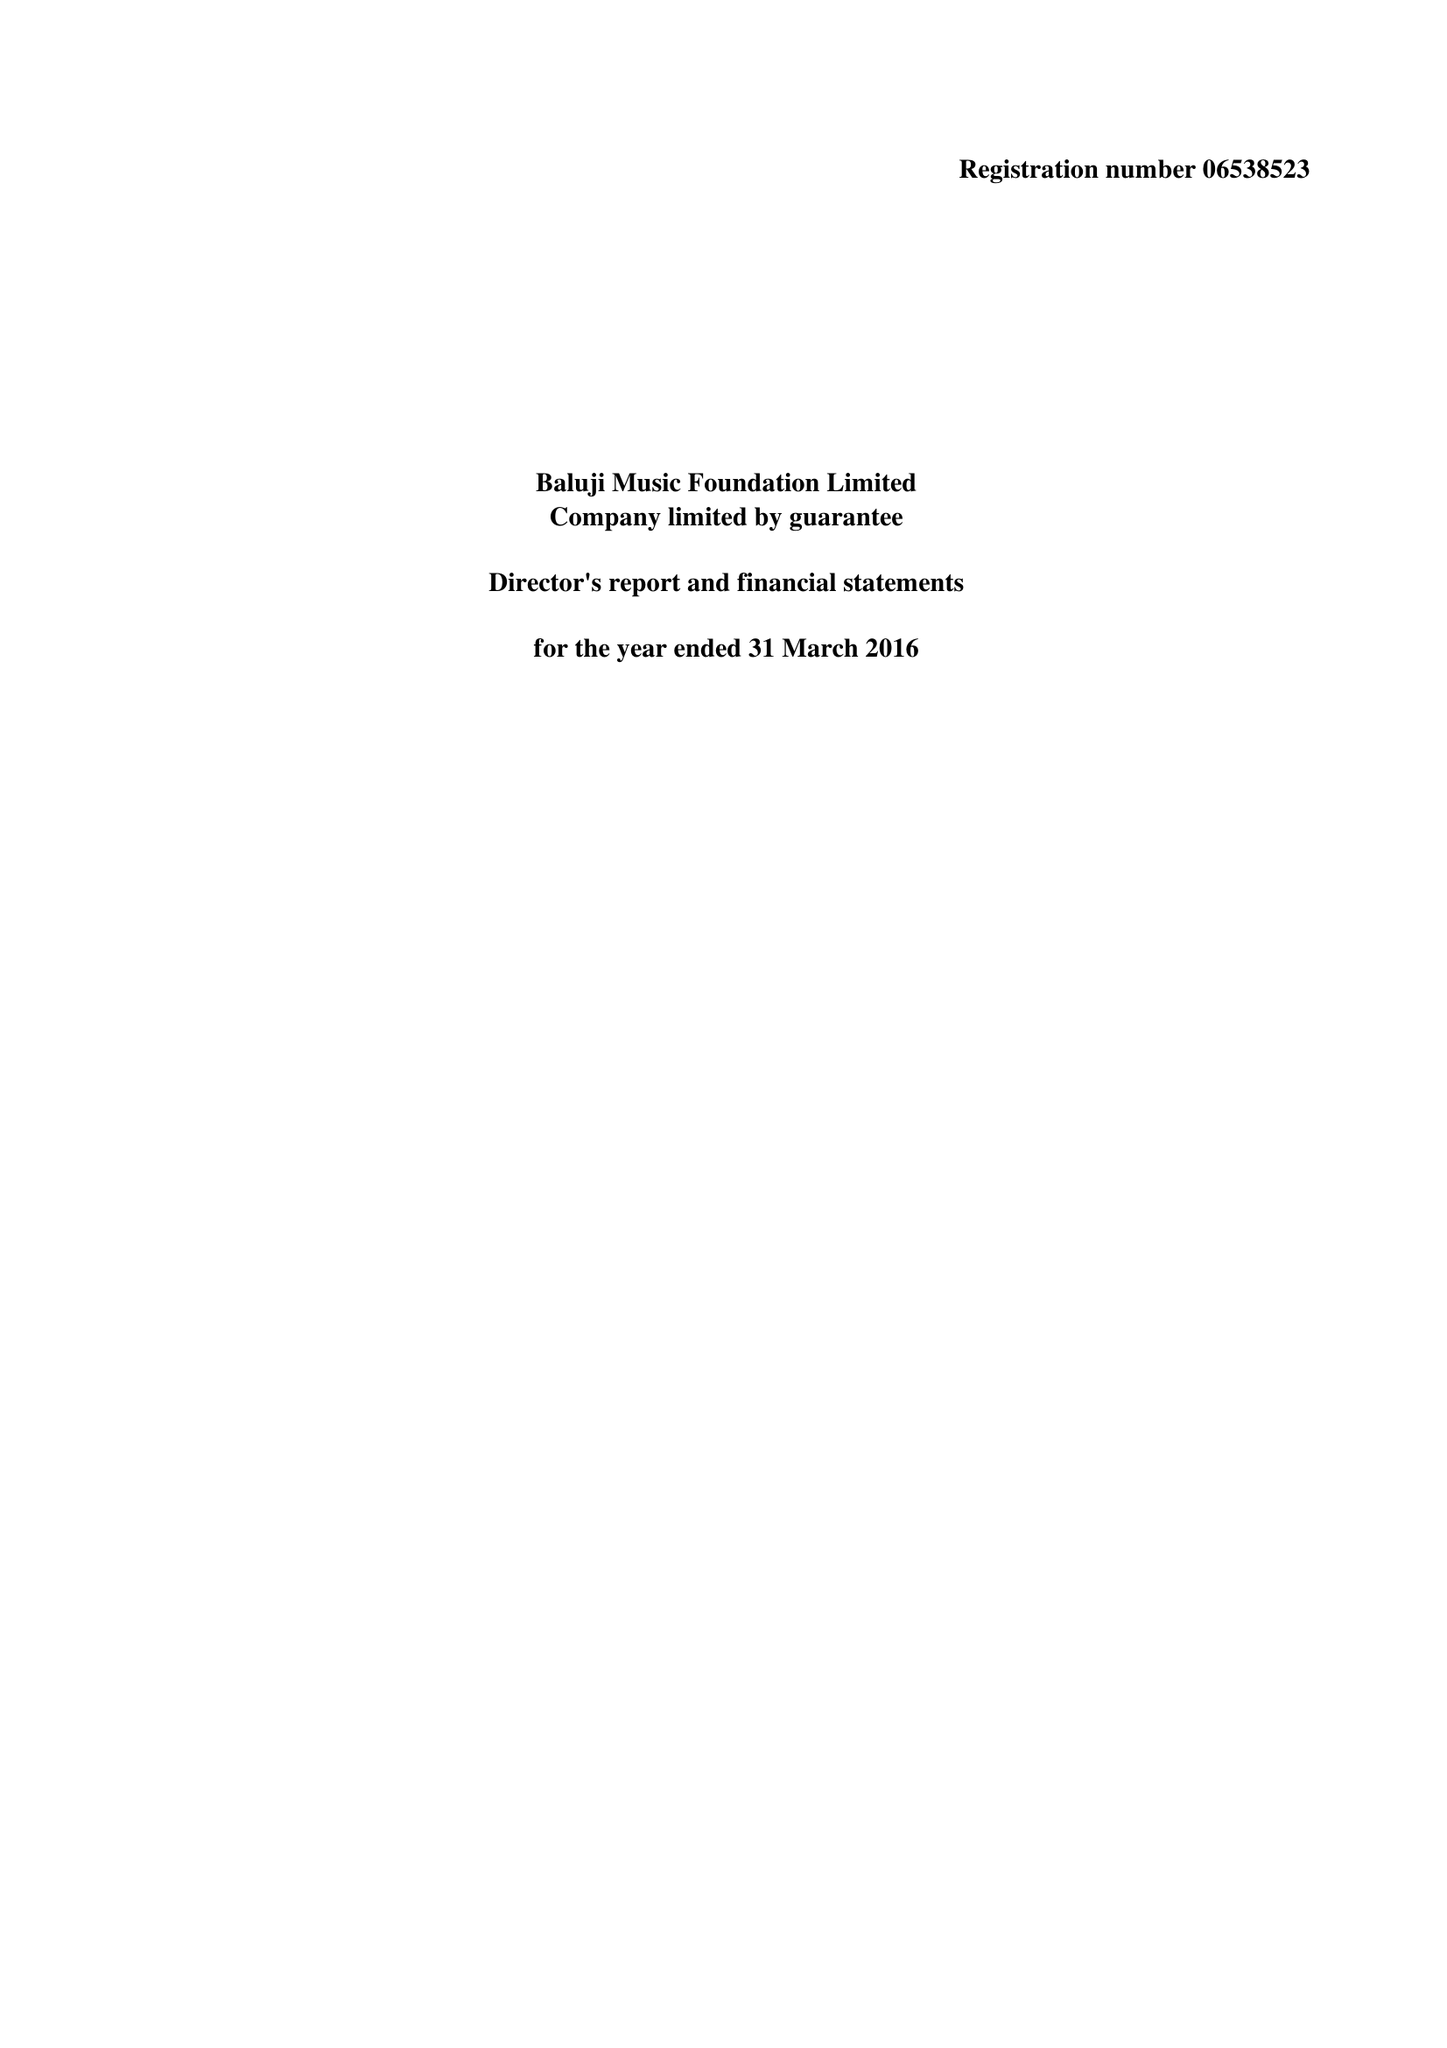What is the value for the address__street_line?
Answer the question using a single word or phrase. 33 NORTHOLME ROAD 